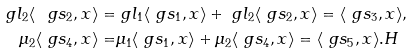Convert formula to latex. <formula><loc_0><loc_0><loc_500><loc_500>\ g l _ { 2 } \langle \ g s _ { 2 } , x \rangle = & \ g l _ { 1 } \langle \ g s _ { 1 } , x \rangle + \ g l _ { 2 } \langle \ g s _ { 2 } , x \rangle = \langle \ g s _ { 3 } , x \rangle , \\ \mu _ { 2 } \langle \ g s _ { 4 } , x \rangle = & \mu _ { 1 } \langle \ g s _ { 1 } , x \rangle + \mu _ { 2 } \langle \ g s _ { 4 } , x \rangle = \langle \ g s _ { 5 } , x \rangle . H</formula> 